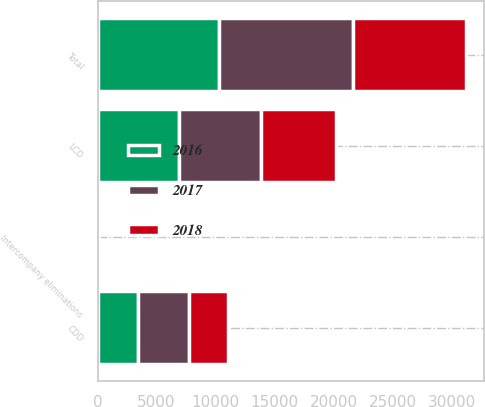<chart> <loc_0><loc_0><loc_500><loc_500><stacked_bar_chart><ecel><fcel>LCD<fcel>CDD<fcel>Intercompany eliminations<fcel>Total<nl><fcel>2017<fcel>7030.8<fcel>4313.1<fcel>10.5<fcel>11333.4<nl><fcel>2016<fcel>6858.2<fcel>3451.6<fcel>1.8<fcel>10308<nl><fcel>2018<fcel>6307.6<fcel>3245.8<fcel>0.5<fcel>9552.9<nl></chart> 